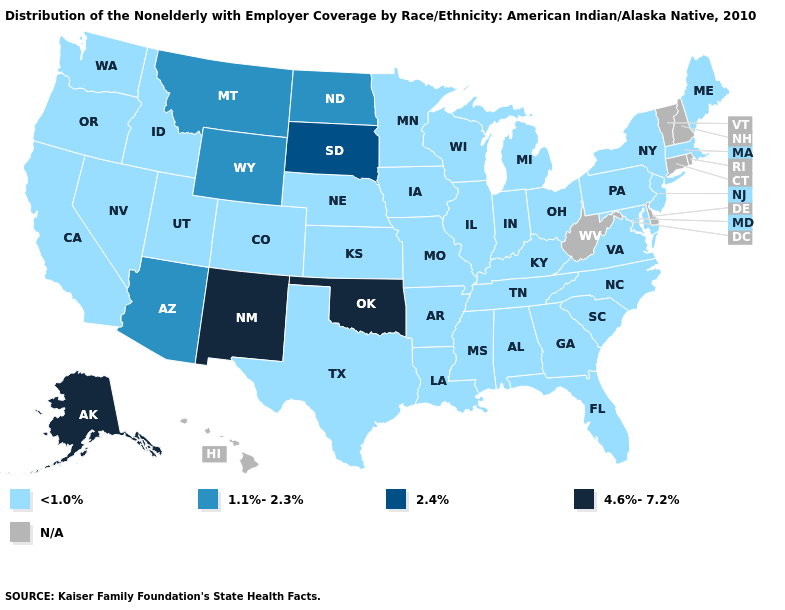Is the legend a continuous bar?
Concise answer only. No. What is the value of North Carolina?
Short answer required. <1.0%. Which states have the lowest value in the West?
Be succinct. California, Colorado, Idaho, Nevada, Oregon, Utah, Washington. Does Louisiana have the highest value in the South?
Answer briefly. No. Name the states that have a value in the range 2.4%?
Answer briefly. South Dakota. What is the lowest value in the MidWest?
Short answer required. <1.0%. Which states have the lowest value in the USA?
Short answer required. Alabama, Arkansas, California, Colorado, Florida, Georgia, Idaho, Illinois, Indiana, Iowa, Kansas, Kentucky, Louisiana, Maine, Maryland, Massachusetts, Michigan, Minnesota, Mississippi, Missouri, Nebraska, Nevada, New Jersey, New York, North Carolina, Ohio, Oregon, Pennsylvania, South Carolina, Tennessee, Texas, Utah, Virginia, Washington, Wisconsin. Does South Dakota have the highest value in the MidWest?
Quick response, please. Yes. Name the states that have a value in the range 2.4%?
Write a very short answer. South Dakota. Name the states that have a value in the range <1.0%?
Short answer required. Alabama, Arkansas, California, Colorado, Florida, Georgia, Idaho, Illinois, Indiana, Iowa, Kansas, Kentucky, Louisiana, Maine, Maryland, Massachusetts, Michigan, Minnesota, Mississippi, Missouri, Nebraska, Nevada, New Jersey, New York, North Carolina, Ohio, Oregon, Pennsylvania, South Carolina, Tennessee, Texas, Utah, Virginia, Washington, Wisconsin. Name the states that have a value in the range 2.4%?
Keep it brief. South Dakota. What is the value of Montana?
Write a very short answer. 1.1%-2.3%. 